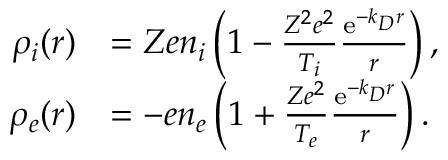Convert formula to latex. <formula><loc_0><loc_0><loc_500><loc_500>\begin{array} { r l } { \rho _ { i } ( r ) } & { = Z e n _ { i } \left ( 1 - \frac { Z ^ { 2 } e ^ { 2 } } { T _ { i } } \frac { e ^ { - k _ { D } r } } { r } \right ) , } \\ { \rho _ { e } ( r ) } & { = - e n _ { e } \left ( 1 + \frac { Z e ^ { 2 } } { T _ { e } } \frac { e ^ { - k _ { D } r } } { r } \right ) . } \end{array}</formula> 